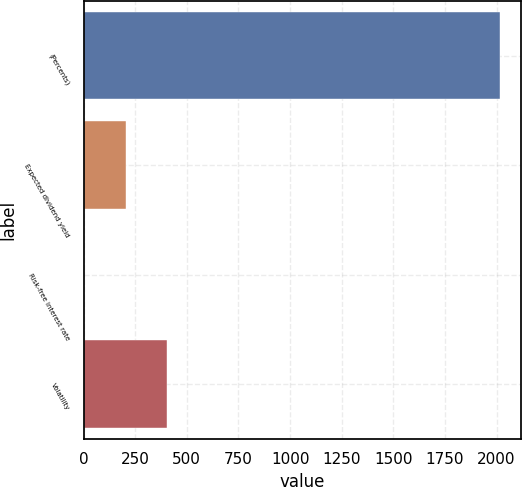Convert chart. <chart><loc_0><loc_0><loc_500><loc_500><bar_chart><fcel>(Percents)<fcel>Expected dividend yield<fcel>Risk-free interest rate<fcel>Volatility<nl><fcel>2018<fcel>203.88<fcel>2.31<fcel>405.45<nl></chart> 